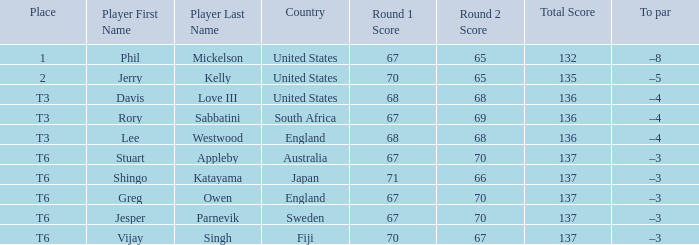Name the score for vijay singh 70-67=137. 